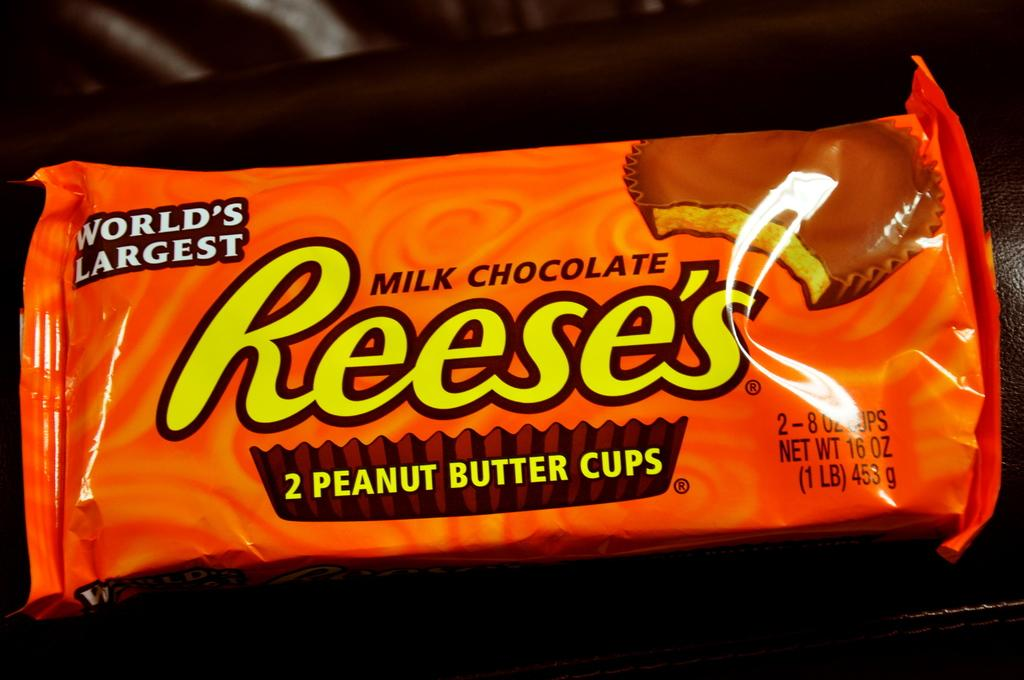<image>
Offer a succinct explanation of the picture presented. 2 reeses peanut butter cups in an orange package 